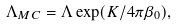Convert formula to latex. <formula><loc_0><loc_0><loc_500><loc_500>\Lambda _ { M C } = \Lambda \exp ( K / 4 \pi \beta _ { 0 } ) ,</formula> 